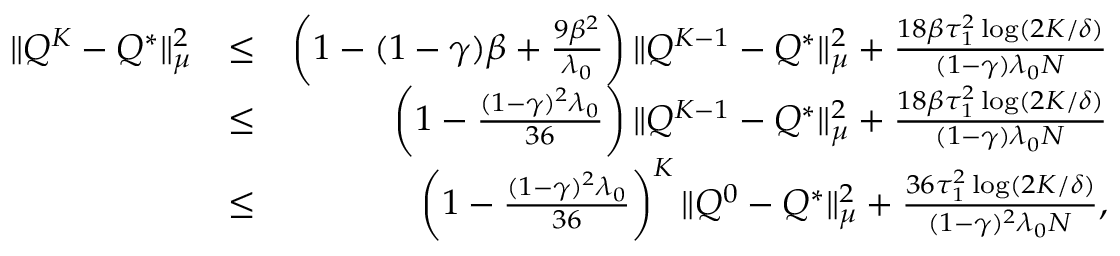<formula> <loc_0><loc_0><loc_500><loc_500>\begin{array} { r l r } { \| Q ^ { K } - Q ^ { * } \| _ { \mu } ^ { 2 } } & { \leq } & { \left ( 1 - ( 1 - \gamma ) \beta + \frac { 9 \beta ^ { 2 } } { \lambda _ { 0 } } \right ) \| Q ^ { K - 1 } - Q ^ { * } \| _ { \mu } ^ { 2 } + \frac { 1 8 \beta \tau _ { 1 } ^ { 2 } \log ( 2 K / \delta ) } { ( 1 - \gamma ) \lambda _ { 0 } N } } \\ & { \leq } & { \left ( 1 - \frac { ( 1 - \gamma ) ^ { 2 } \lambda _ { 0 } } { 3 6 } \right ) \| Q ^ { K - 1 } - Q ^ { * } \| _ { \mu } ^ { 2 } + \frac { 1 8 \beta \tau _ { 1 } ^ { 2 } \log ( 2 K / \delta ) } { ( 1 - \gamma ) \lambda _ { 0 } N } } \\ & { \leq } & { \left ( 1 - \frac { ( 1 - \gamma ) ^ { 2 } \lambda _ { 0 } } { 3 6 } \right ) ^ { K } \| Q ^ { 0 } - Q ^ { * } \| _ { \mu } ^ { 2 } + \frac { 3 6 \tau _ { 1 } ^ { 2 } \log ( 2 K / \delta ) } { ( 1 - \gamma ) ^ { 2 } \lambda _ { 0 } N } , } \end{array}</formula> 